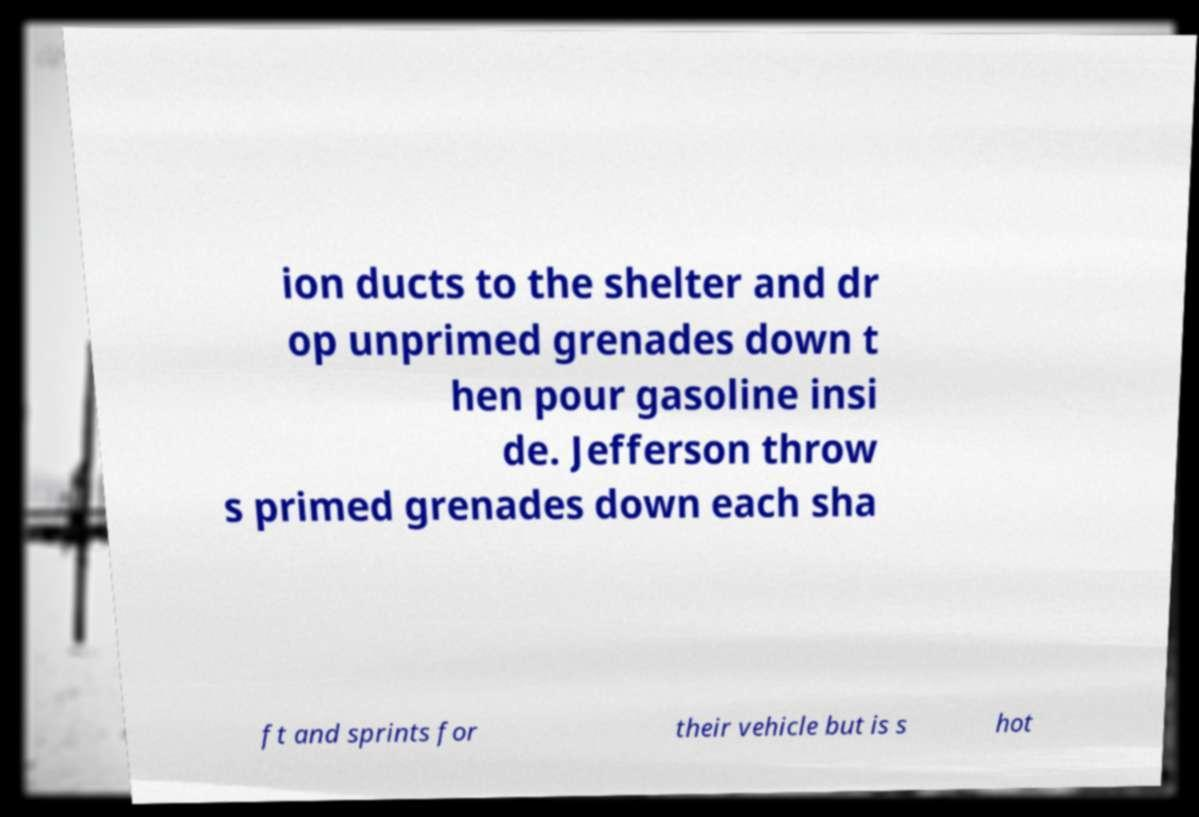There's text embedded in this image that I need extracted. Can you transcribe it verbatim? ion ducts to the shelter and dr op unprimed grenades down t hen pour gasoline insi de. Jefferson throw s primed grenades down each sha ft and sprints for their vehicle but is s hot 